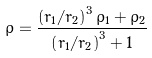<formula> <loc_0><loc_0><loc_500><loc_500>\bar { \rho } = \frac { \left ( { r _ { 1 } / r _ { 2 } } \right ) ^ { 3 } \rho _ { 1 } + \rho _ { 2 } } { \left ( { r _ { 1 } / r _ { 2 } } \right ) ^ { 3 } + 1 }</formula> 